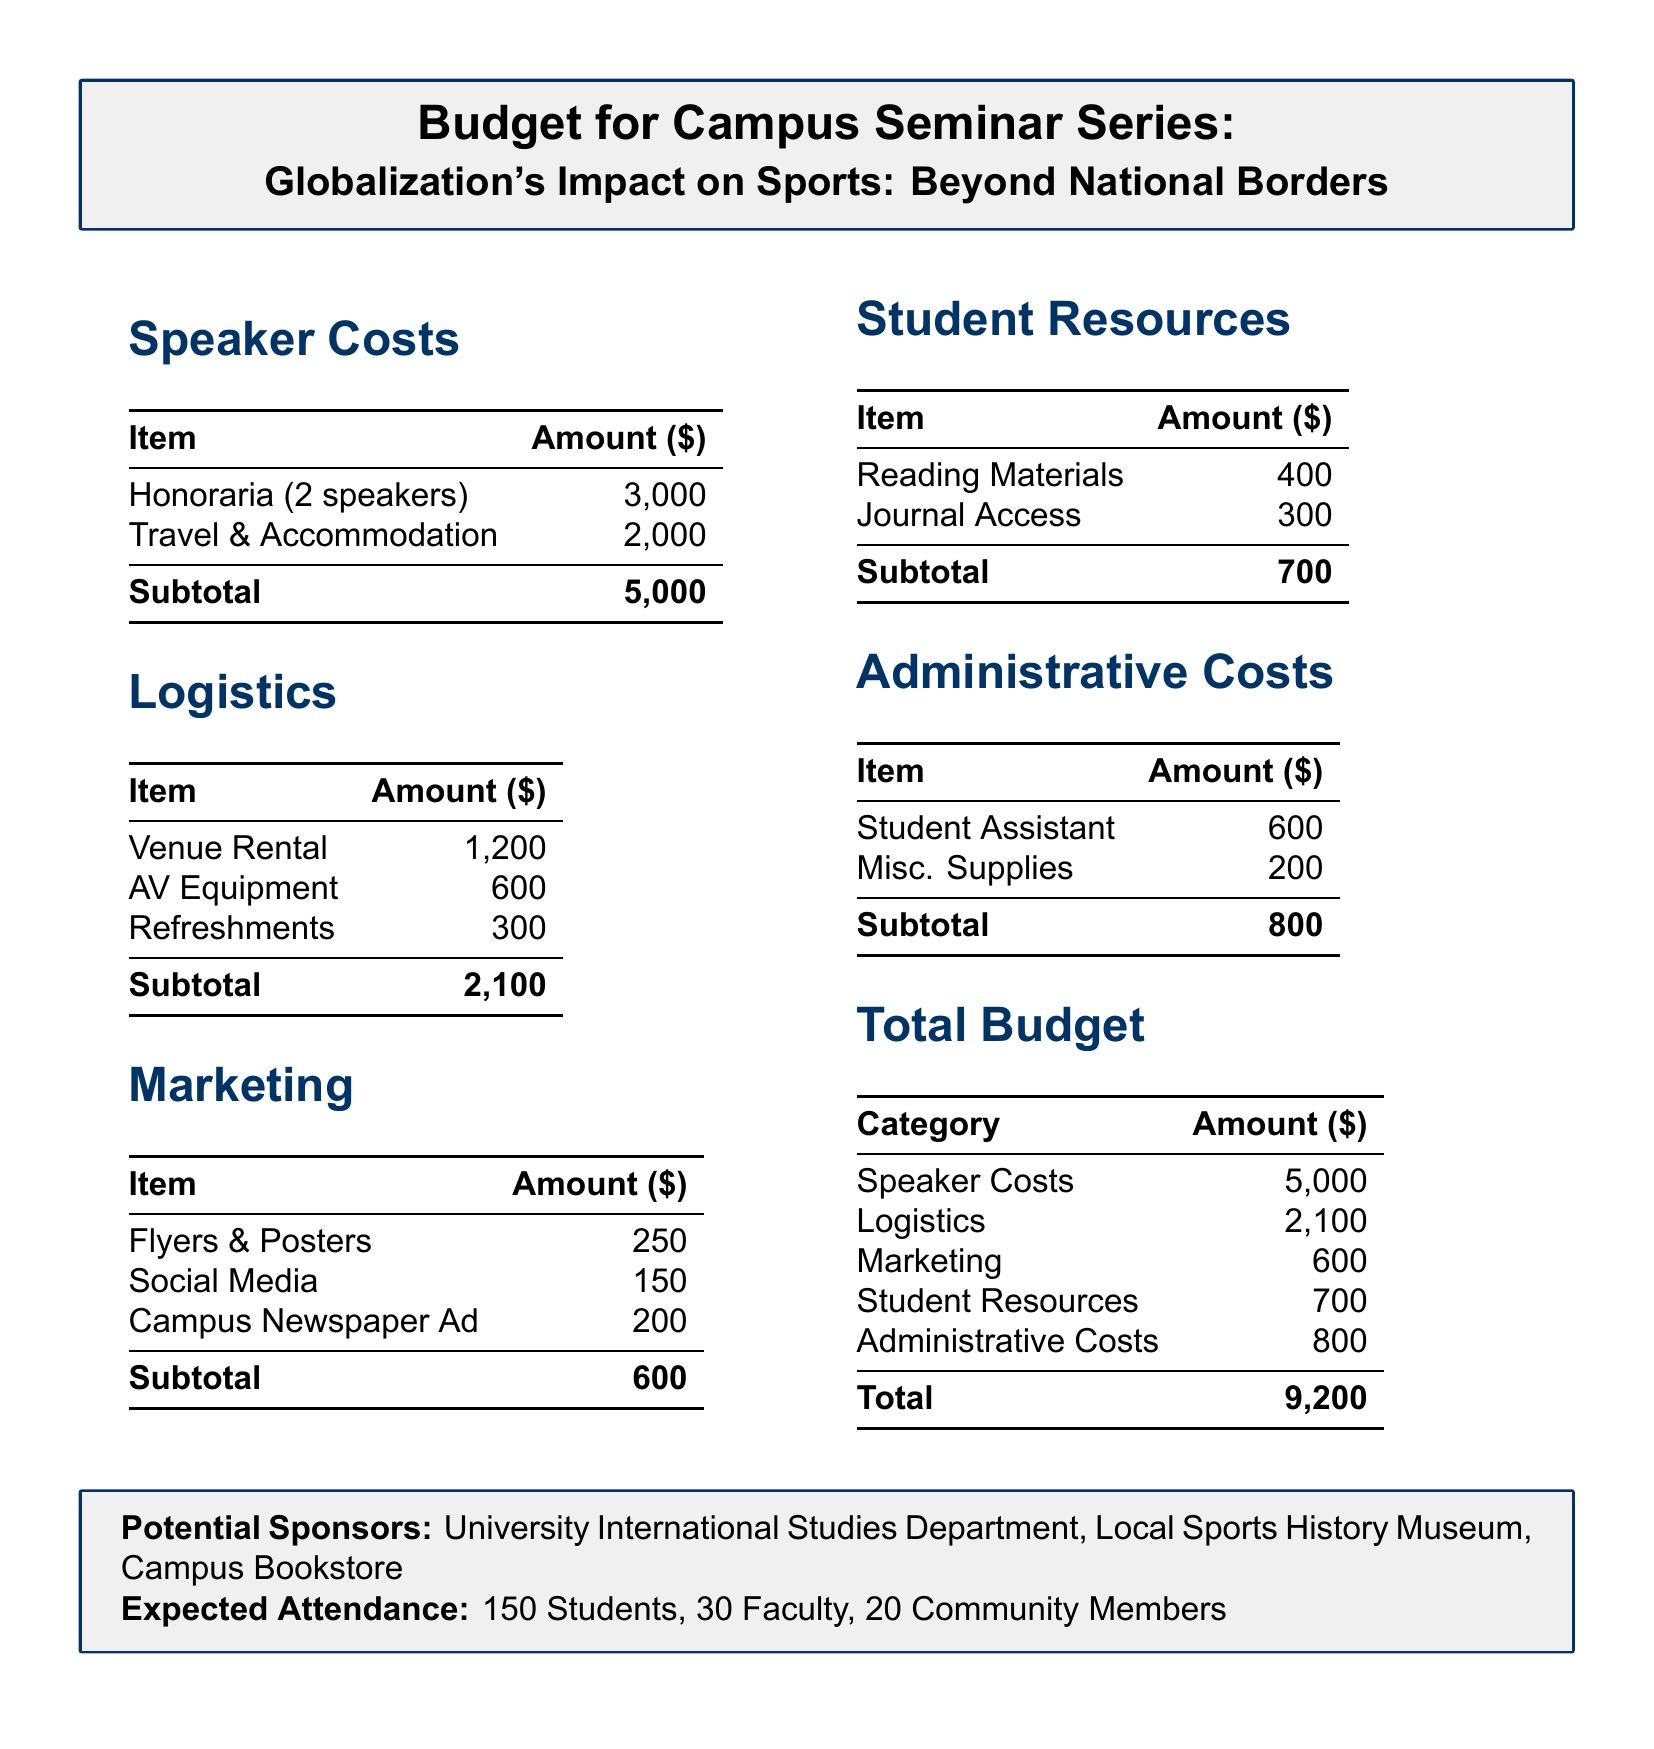what is the total budget? The total budget is the sum of all categories listed in the document: 5000 + 2100 + 600 + 700 + 800, which equals 9200.
Answer: 9200 how many speakers are planned for the seminar? The document specifies that there will be 2 speakers for the seminar series.
Answer: 2 what is the amount allocated for student resources? The budget document shows that the amount allocated for student resources is 700.
Answer: 700 what is the cost for venue rental? The cost for venue rental is listed separately under logistics, which is 1200.
Answer: 1200 who are the potential sponsors mentioned in the document? The document states three potential sponsors: University International Studies Department, Local Sports History Museum, and Campus Bookstore.
Answer: University International Studies Department, Local Sports History Museum, Campus Bookstore what is the total amount for logistics? The logistics section totals the rental, equipment, and refreshments costs, summing up to 2100.
Answer: 2100 how many total people are expected to attend the seminar? The document mentions an expected attendance of 150 students, 30 faculty, and 20 community members, which totals 200.
Answer: 200 what item has the highest cost in the speaker costs section? The highest cost in the speaker costs section is the honoraria for 2 speakers, which is 3000.
Answer: 3000 what is the amount set aside for marketing? The document indicates that the budget for marketing items totals 600.
Answer: 600 